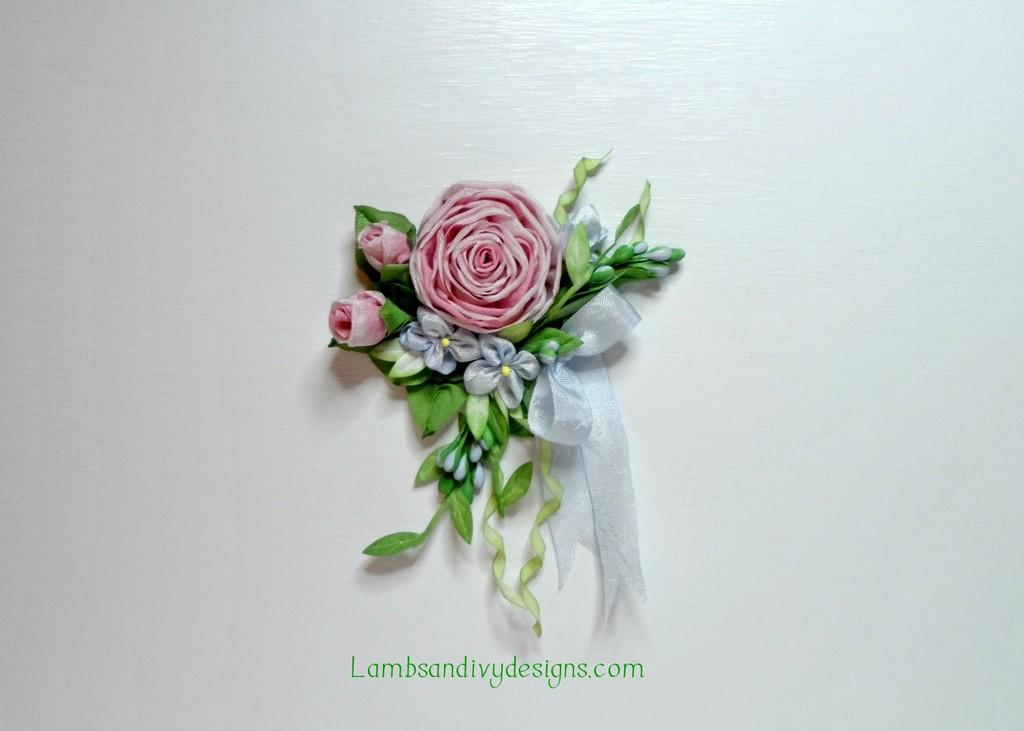What type of plant life is present in the image? There are flowers and leaves in the image. What additional element can be seen in the image? There is a ribbon in the image. What color is the background of the image? The background of the image is white. Where is the text located in the image? The text is at the bottom of the image. Can you describe the growth of the sea in the image? There is no sea present in the image, so it is not possible to describe its growth. 